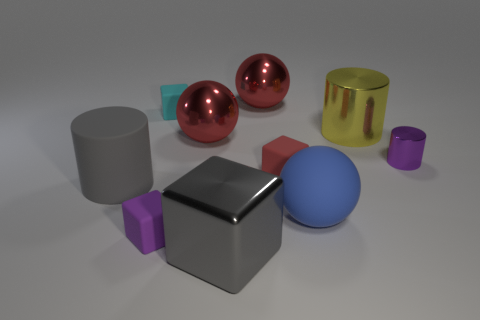What is the size of the rubber cube that is the same color as the small metallic cylinder?
Your response must be concise. Small. What material is the large block that is the same color as the matte cylinder?
Provide a short and direct response. Metal. The big cylinder that is made of the same material as the blue thing is what color?
Your answer should be very brief. Gray. Is the number of metallic cylinders that are behind the purple metallic cylinder the same as the number of small blue blocks?
Provide a short and direct response. No. The blue object that is the same size as the gray shiny object is what shape?
Your response must be concise. Sphere. What number of other things are there of the same shape as the tiny purple matte object?
Give a very brief answer. 3. Does the cyan rubber cube have the same size as the shiny thing in front of the gray rubber thing?
Give a very brief answer. No. What number of things are either cylinders on the left side of the purple rubber thing or red things?
Provide a short and direct response. 4. There is a purple object that is in front of the tiny metal thing; what is its shape?
Your answer should be compact. Cube. Are there the same number of small matte cubes in front of the big gray block and cyan blocks in front of the red rubber block?
Your response must be concise. Yes. 